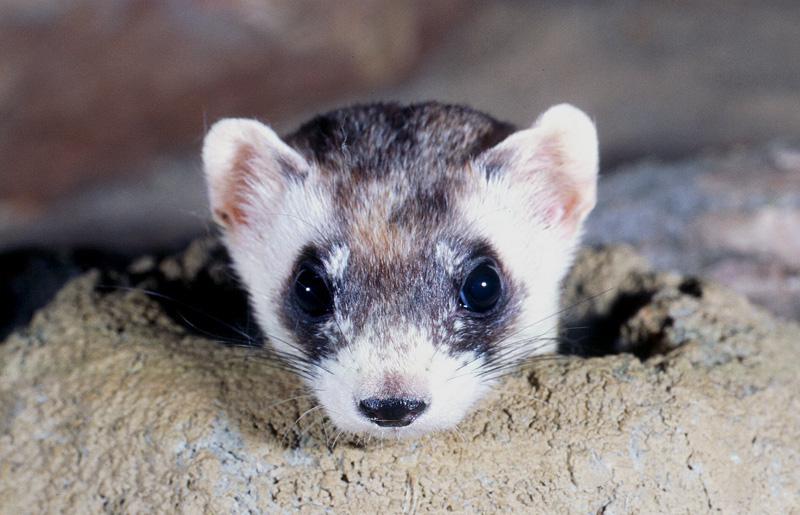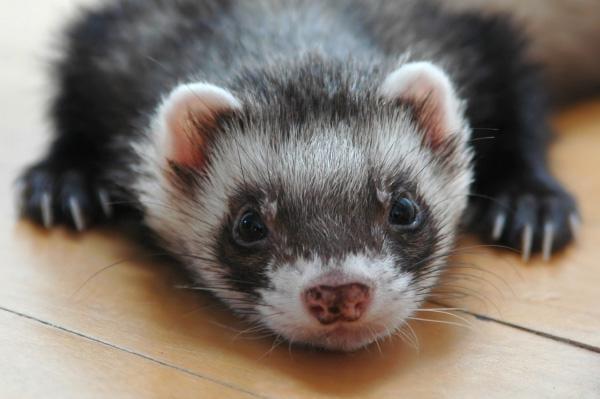The first image is the image on the left, the second image is the image on the right. For the images shown, is this caption "The left animal is mostly underground, the right animal is entirely above ground." true? Answer yes or no. Yes. 